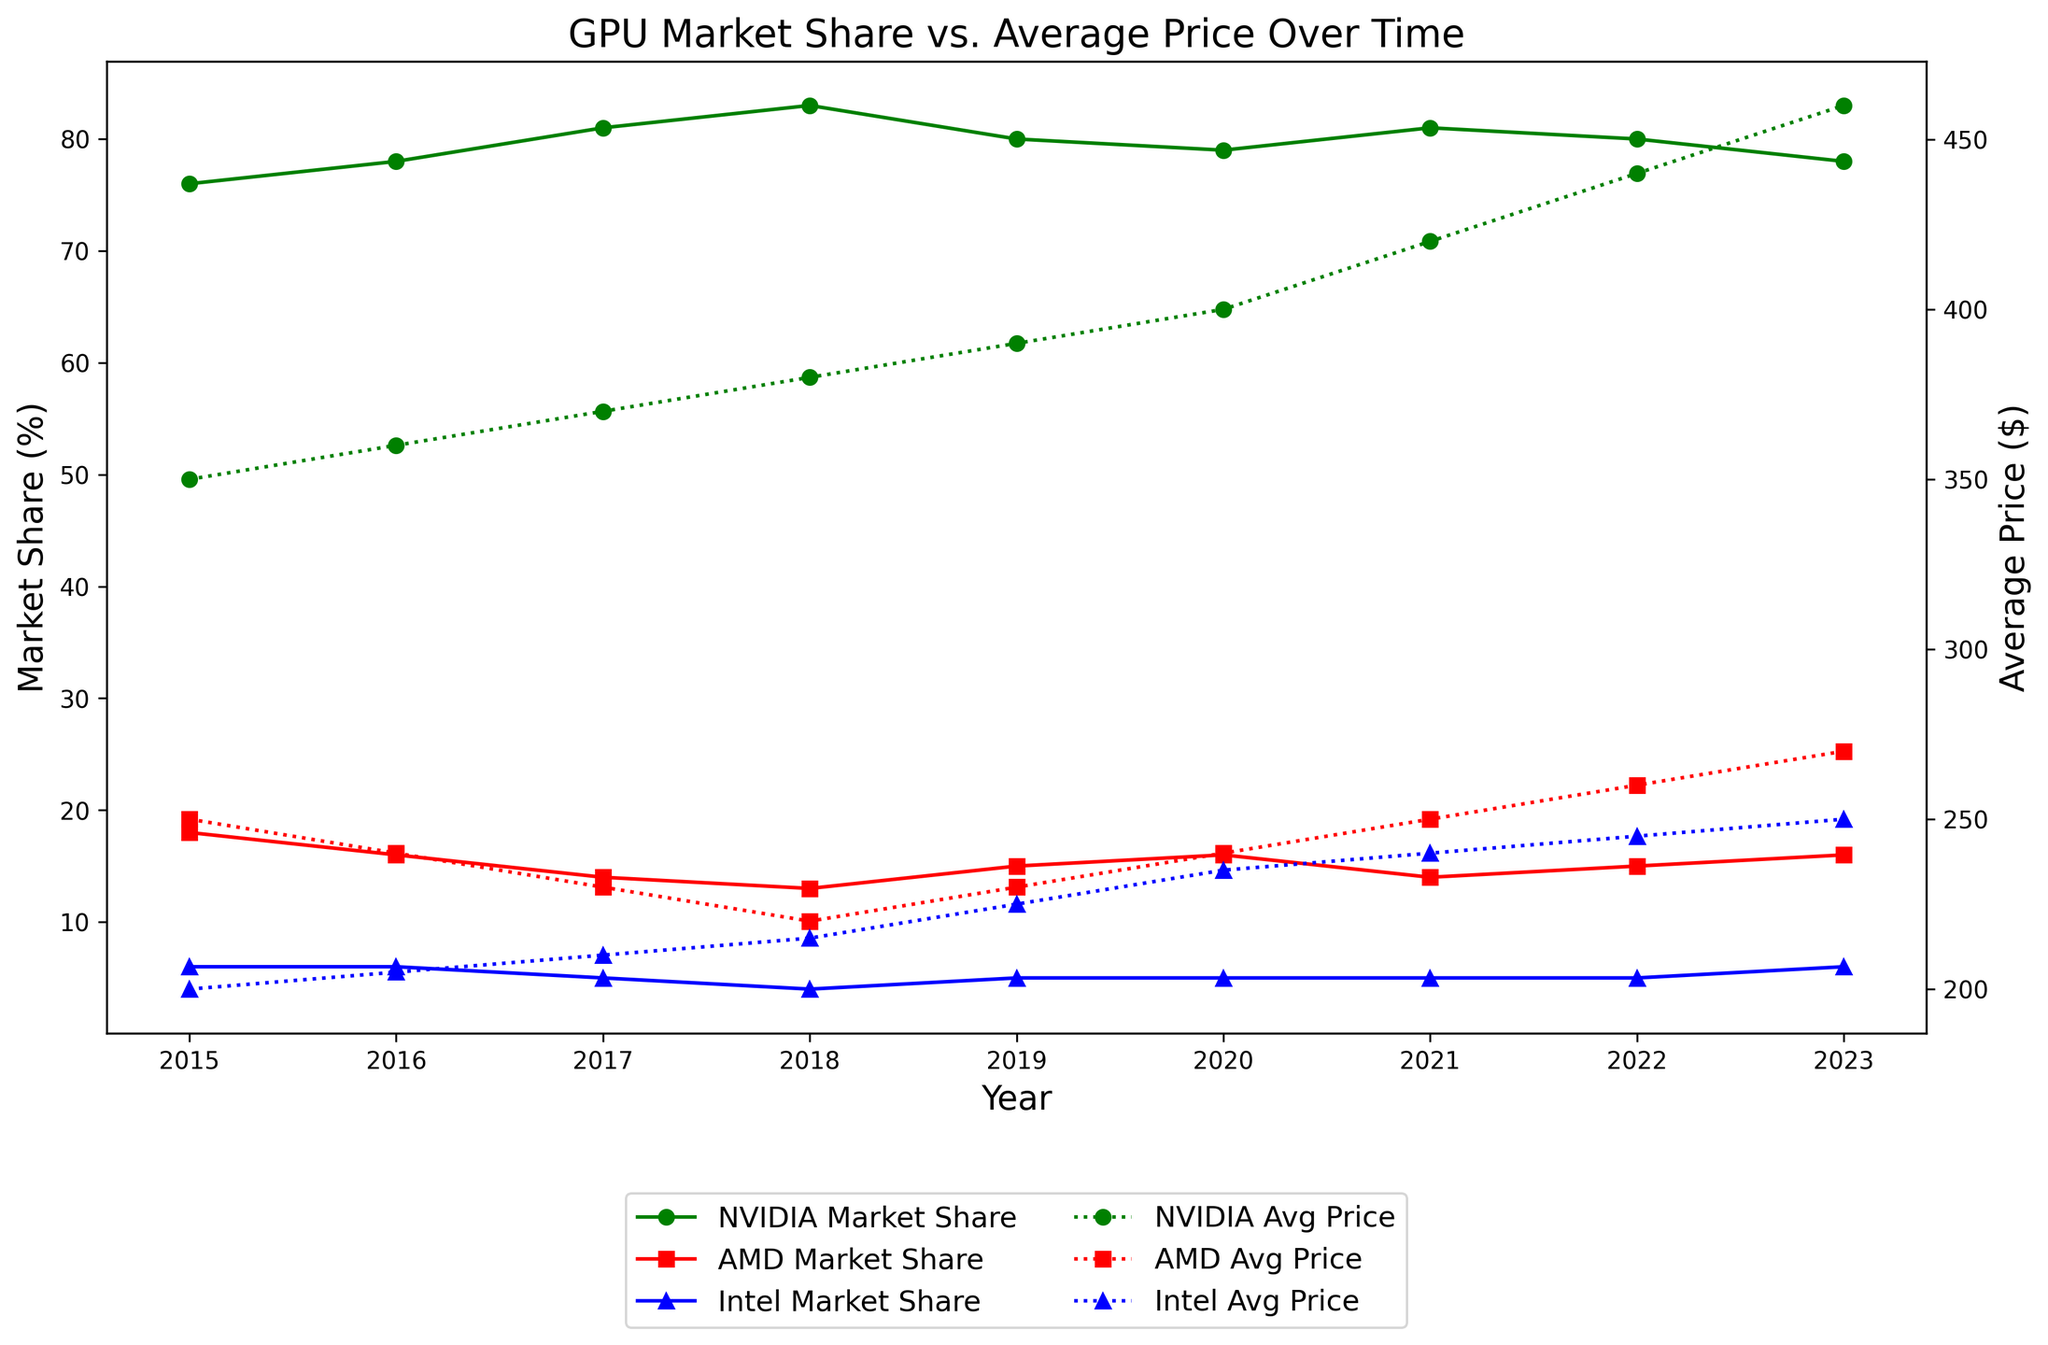What year did NVIDIA have the highest market share? From the plot, we can see that NVIDIA's market share peaked at 83% in 2018. This is the highest value compared to other years.
Answer: 2018 Which company had the lowest market share in 2023? Checking the market share lines for 2023: NVIDIA had 78%, AMD had 16%, and Intel had 6%. So, Intel had the lowest market share in 2023.
Answer: Intel What was the difference in the average price of NVIDIA GPUs between 2020 and 2023? In 2020, the average price of NVIDIA GPUs was $400, and in 2023, it was $460. The difference is $460 - $400 = $60.
Answer: $60 How did AMD's market share change from 2015 to 2023? AMD's market share in 2015 was 18%, and it was 16% in 2023. The change is 16% - 18% = -2%. Thus, AMD's market share decreased by 2 percentage points.
Answer: Decreased by 2% In which year was the average price of AMD GPUs $240? From the plot for average prices, the AMD line is at $240 in 2016 and 2020.
Answer: 2016 and 2020 How many years did Intel's market share stay constant at 5%? According to the plot, Intel had a market share of 5% from 2017 to 2023, which is 7 years.
Answer: 7 years Which company had the highest average price in 2021? Looking at the average price lines for 2021: NVIDIA's average price was $420, AMD's was $250, and Intel's was $240. NVIDIA had the highest average price in 2021.
Answer: NVIDIA Which company showed a consistent increase in market share from 2015 to 2018? According to the market share lines, NVIDIA's market share consistently increased from 76% in 2015 to 83% in 2018.
Answer: NVIDIA Did NVIDIA's average price always increase every year from 2015 to 2023? By examining the NVIDIA average price line every year from 2015 to 2023, the price increases every year without any decrease.
Answer: Yes What is the approximate average price increase per year for AMD GPUs between 2015 and 2023? AMD's average price in 2015 was $250 and in 2023 it was $270. The duration between these years is 2023 - 2015 = 8 years. The total increase in price is $270 - $250 = $20. The average increase per year is $20 / 8 ≈ $2.50.
Answer: $2.50 